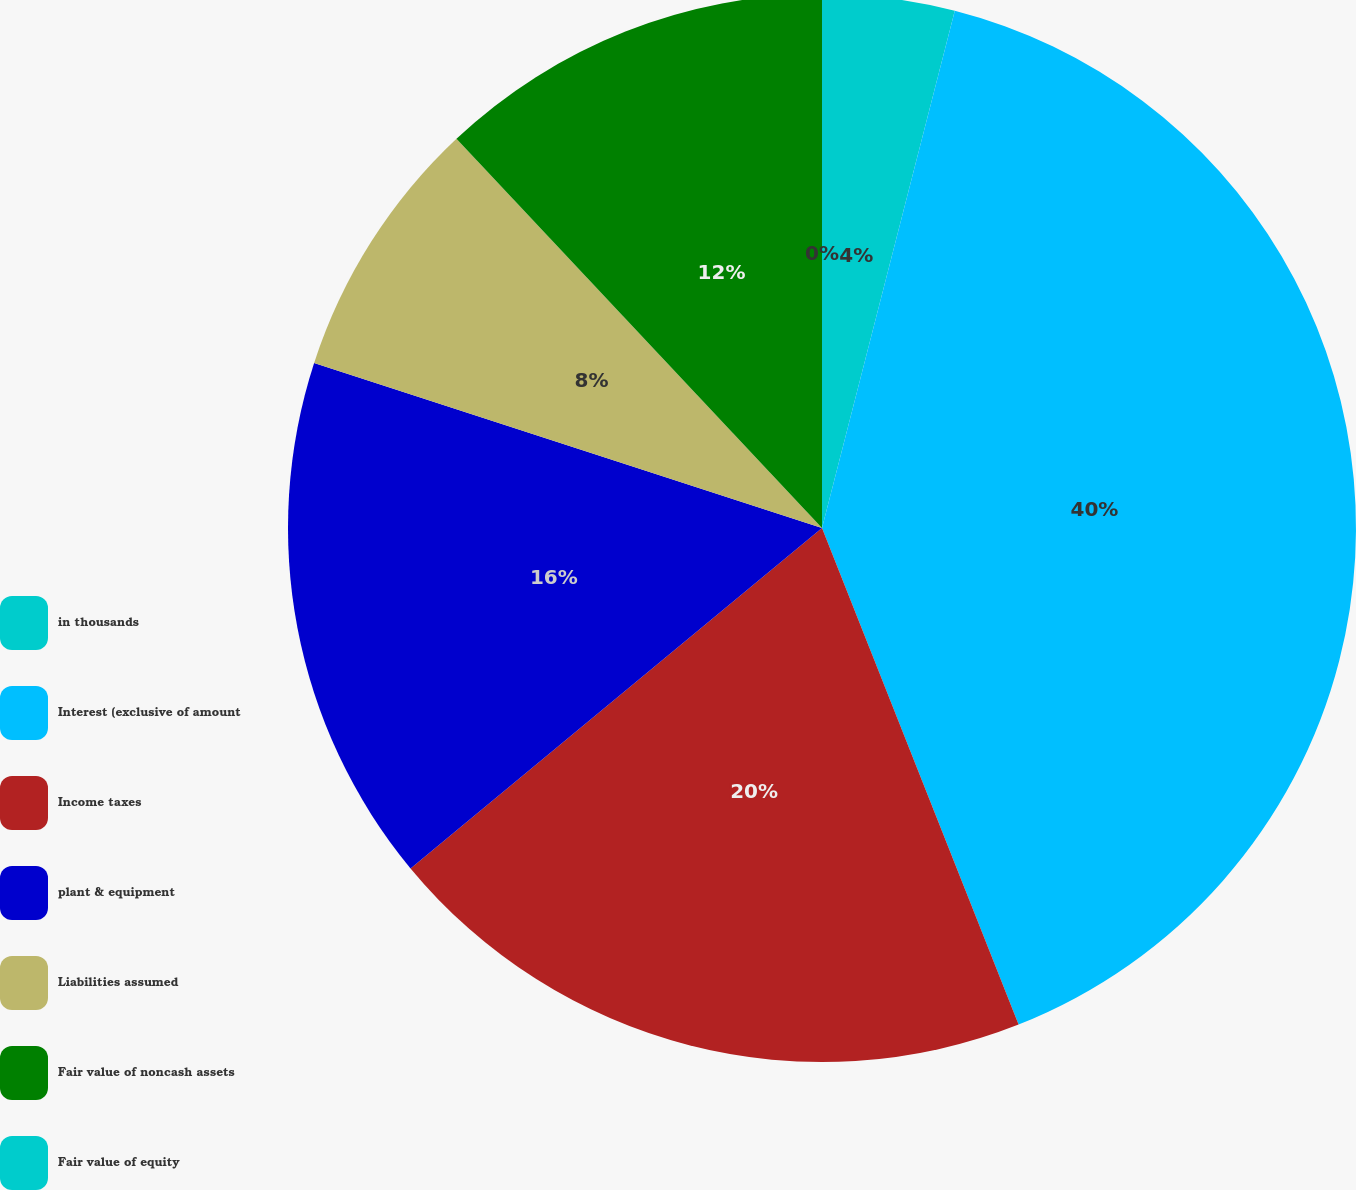Convert chart. <chart><loc_0><loc_0><loc_500><loc_500><pie_chart><fcel>in thousands<fcel>Interest (exclusive of amount<fcel>Income taxes<fcel>plant & equipment<fcel>Liabilities assumed<fcel>Fair value of noncash assets<fcel>Fair value of equity<nl><fcel>4.0%<fcel>40.0%<fcel>20.0%<fcel>16.0%<fcel>8.0%<fcel>12.0%<fcel>0.0%<nl></chart> 